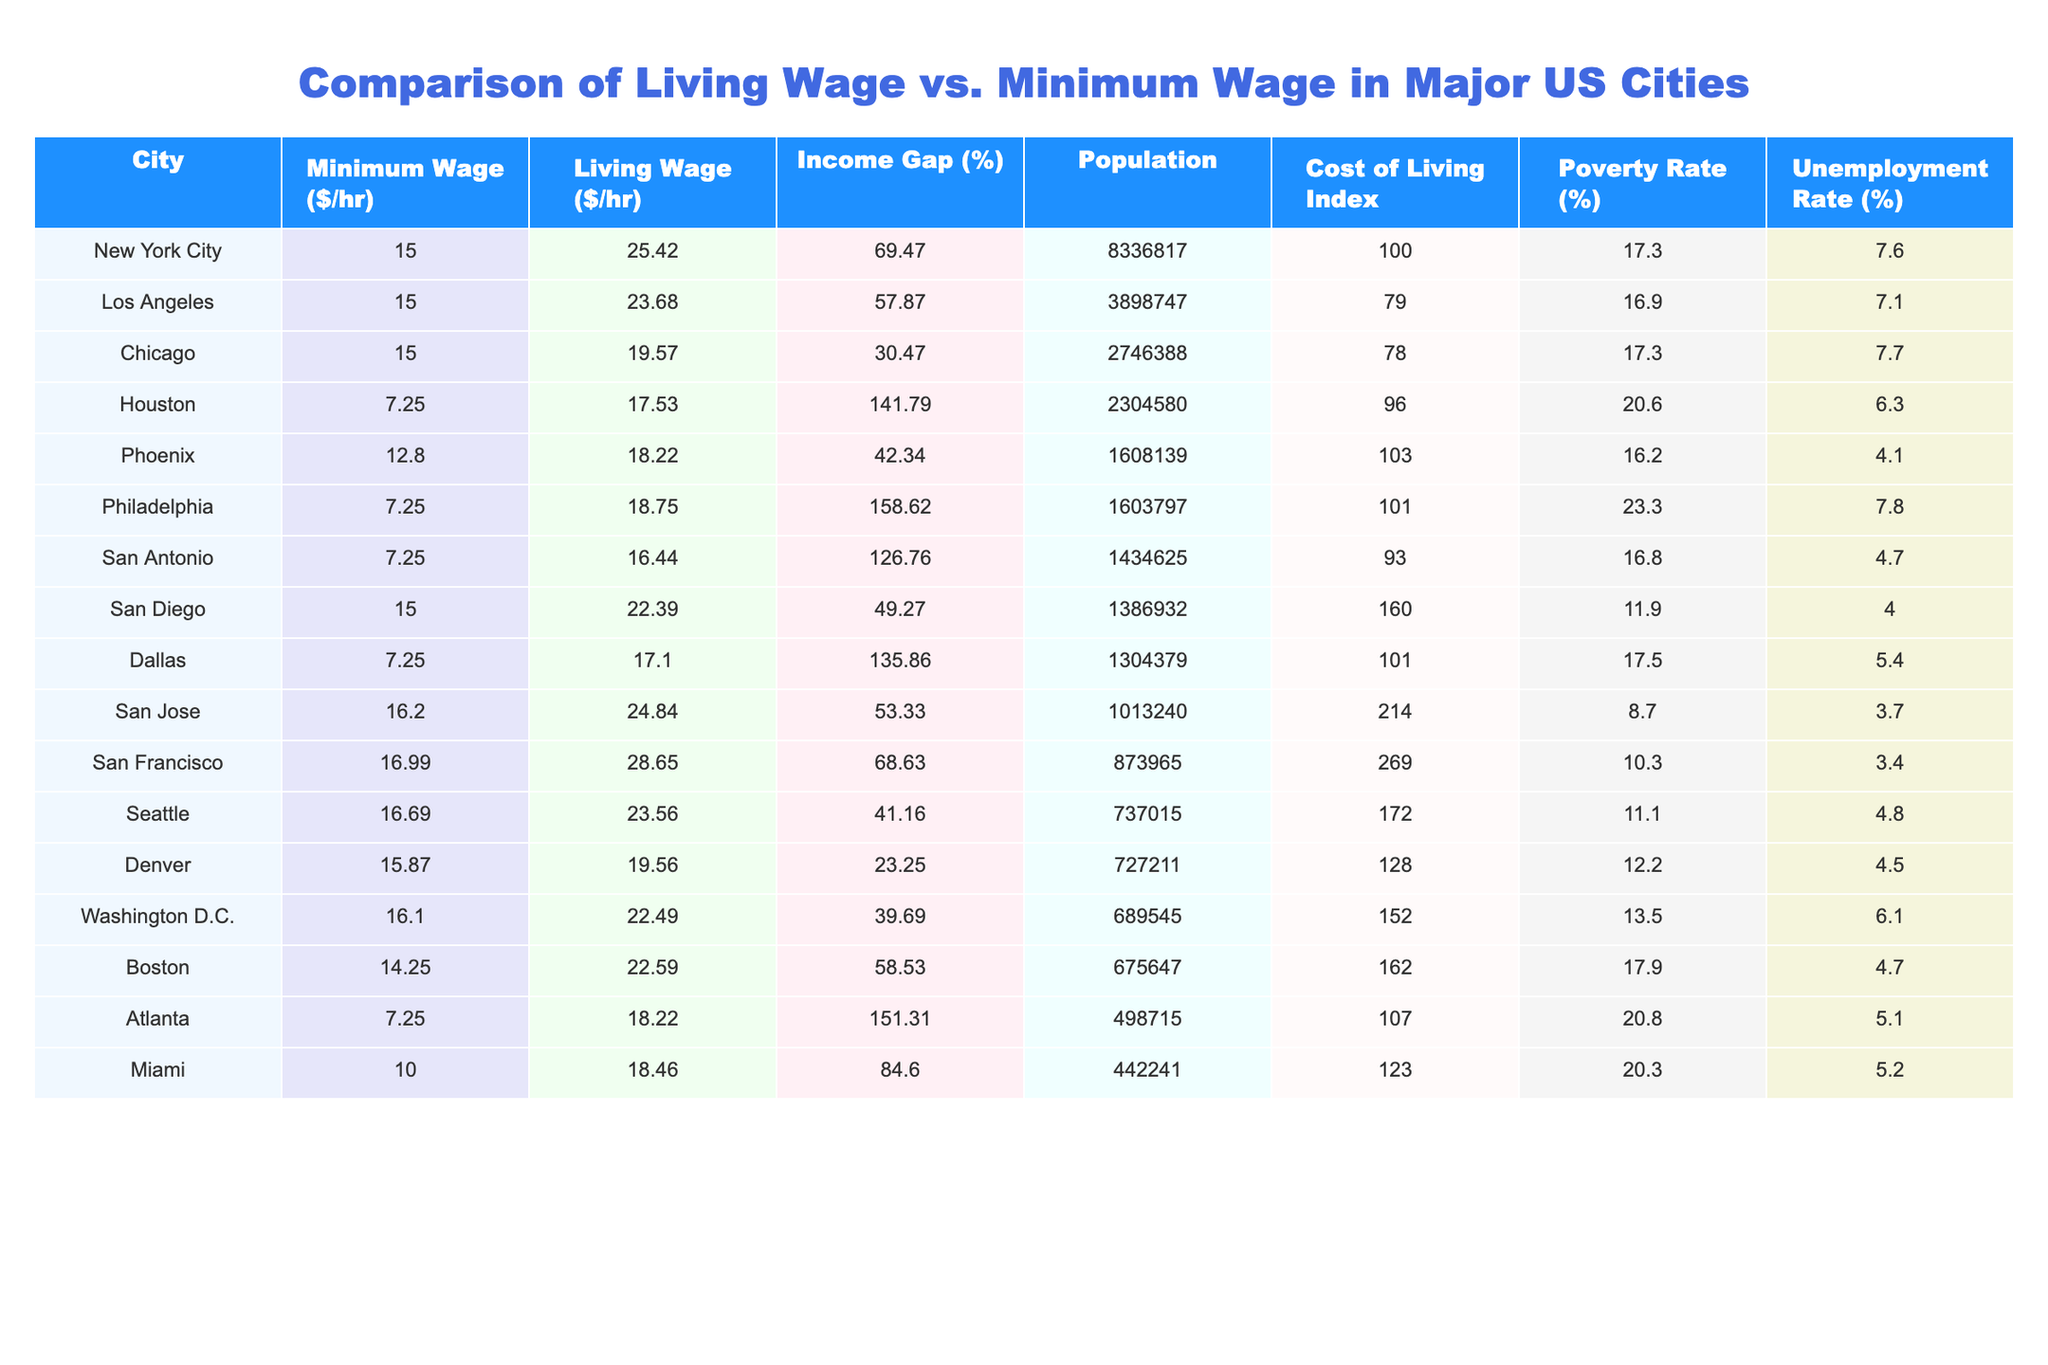What is the minimum wage in San Francisco? The minimum wage in San Francisco is listed as $16.99 per hour in the table.
Answer: 16.99 What is the living wage for New York City? The living wage for New York City is $25.42 per hour according to the table.
Answer: 25.42 Which city has the highest percentage for the income gap? Houston has the highest income gap percentage at 141.79%.
Answer: 141.79% What is the poverty rate in Philadelphia? The poverty rate in Philadelphia is 23.3% as shown in the table.
Answer: 23.3% What is the difference between the living wage and minimum wage in Los Angeles? The living wage in Los Angeles is $23.68, and the minimum wage is $15.00. The difference is calculated as $23.68 - $15.00 = $8.68.
Answer: 8.68 Which city has a higher cost of living index: San Diego or Houston? San Diego has a cost of living index of 160, while Houston has 96. Therefore, San Diego has a higher cost of living index.
Answer: Yes What percentage of the population is unemployed in Chicago? The unemployment rate in Chicago is listed as 7.7% in the table.
Answer: 7.7% Which city has the lowest living wage and what is it? San Antonio has the lowest living wage at $16.44 per hour according to the data.
Answer: 16.44 What is the average minimum wage across all listed cities? To find the average minimum wage, add all minimum wages ($15.00 + $15.00 + $15.00 + $7.25 + $12.80 + $7.25 + $7.25 + $15.00 + $7.25 + $16.20 + $16.99 + $16.69 + $15.87 + $16.10 + $14.25 + $7.25 + $10.00) = $15.45, and divide by the number of cities (15), resulting in an average minimum wage of approximately $11.62.
Answer: 11.62 Which city has both a high living wage and low unemployment rate? Both San Jose and San Francisco have high living wages ($24.84 and $28.65 respectively) and both have unemployment rates below 4%. Therefore, they meet the criteria.
Answer: San Jose and San Francisco How many of the cities listed have a poverty rate above 20%? Checking the table, only Houston (20.6%), Philadelphia (23.3%), and Atlanta (20.8%) have poverty rates above 20%. This accounts for 3 cities.
Answer: 3 